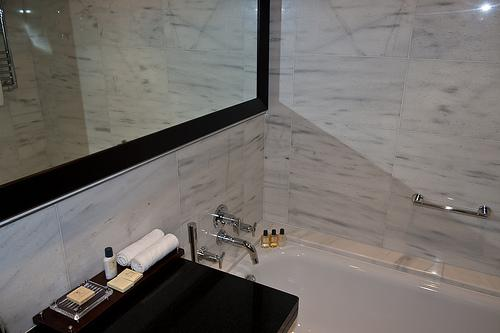Question: how many bottles are on the tub?
Choices:
A. One.
B. Two.
C. Four.
D. Three.
Answer with the letter. Answer: D Question: where are the hand-towels?
Choices:
A. The bathroom.
B. The counter.
C. The closet.
D. In the bag.
Answer with the letter. Answer: B Question: where are the faucets?
Choices:
A. The wall.
B. Outside on the wall of house.
C. In bathroom on sink.
D. In basement on laundry sink.
Answer with the letter. Answer: A Question: what is reflecting the room?
Choices:
A. Mirror.
B. Sunlight.
C. Eyeglasses.
D. Window glass.
Answer with the letter. Answer: A Question: how many bars on the counter?
Choices:
A. One.
B. Three.
C. Two.
D. Four.
Answer with the letter. Answer: B 